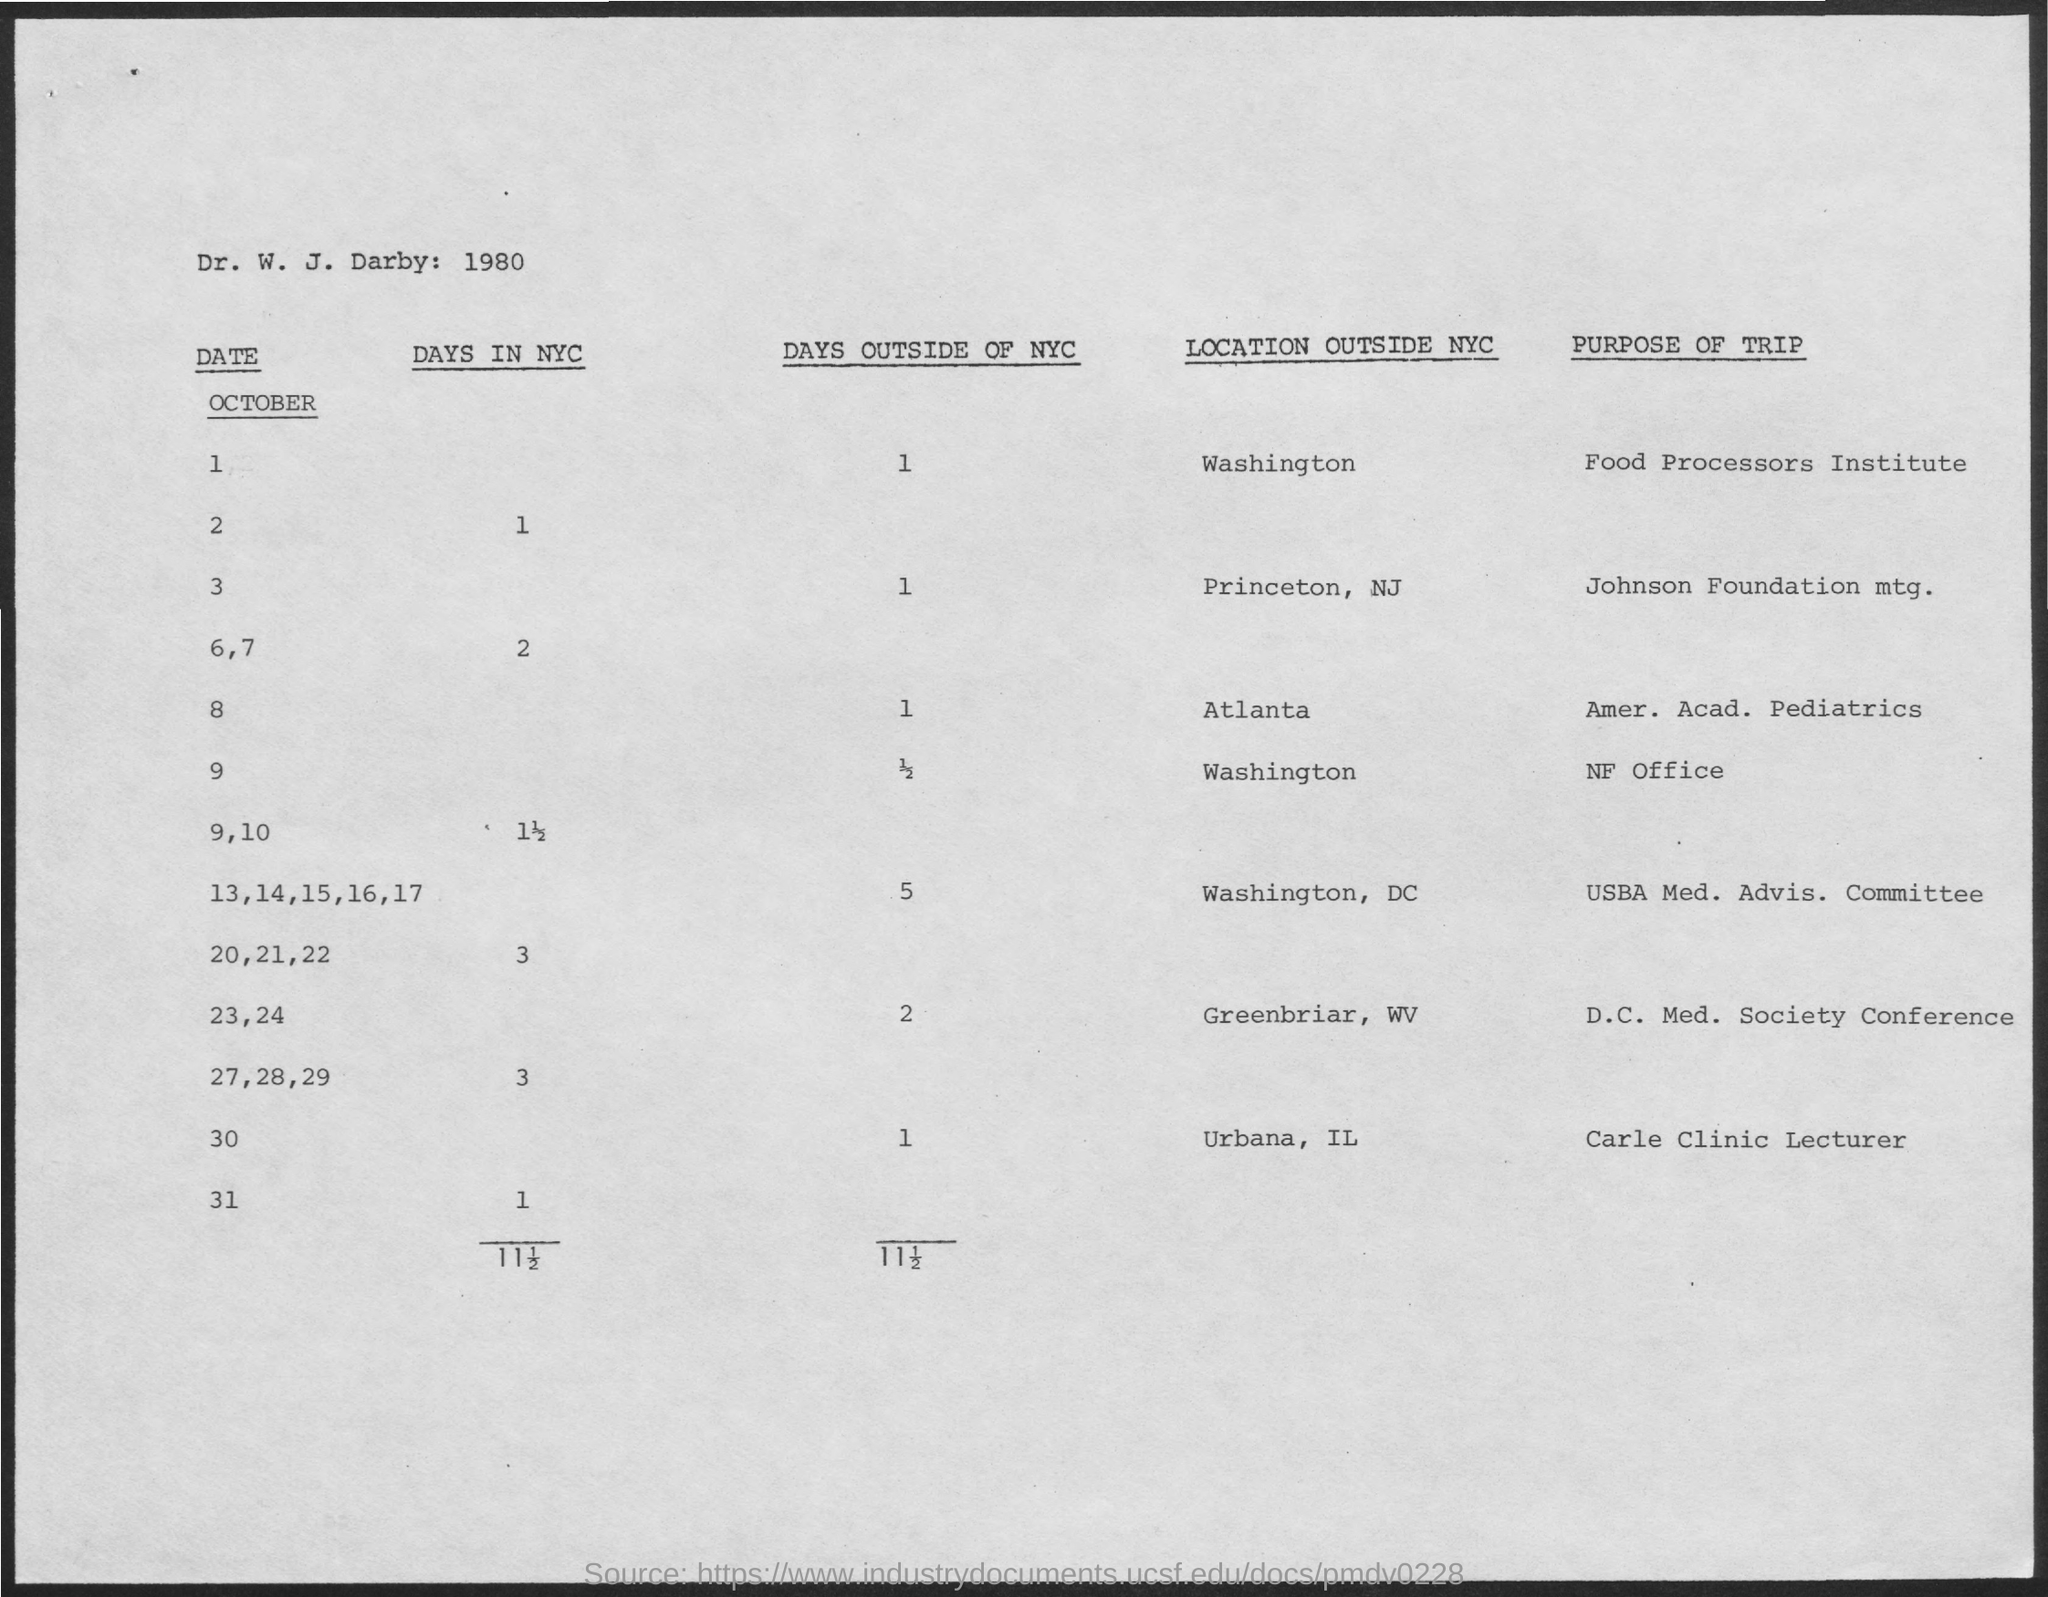Give some essential details in this illustration. On October 1, a trip is planned with the purpose of visiting the Food Processors Institute. On October 8, the location outside of NYC is Atlanta. On October 3, the purpose of the trip is to attend a meeting of the Johnson Foundation. On October 1st, the location outside of New York City is Washington. What is the number of days outside of New York City on October 1st? 